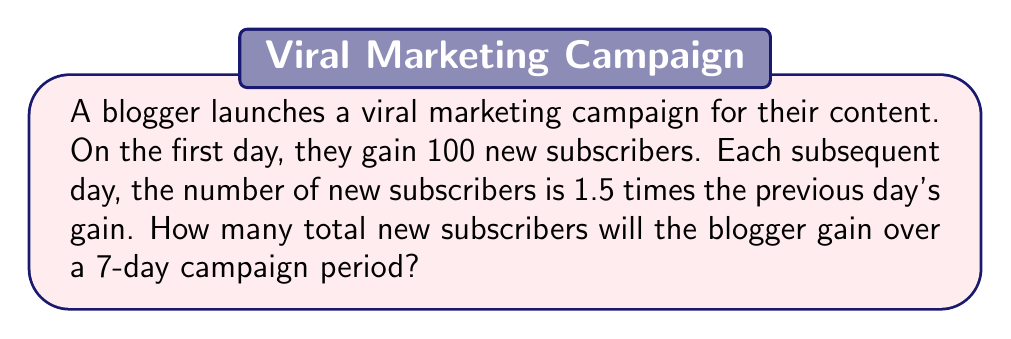Provide a solution to this math problem. Let's approach this step-by-step:

1) We can model this as a geometric sequence with:
   - First term: $a = 100$
   - Common ratio: $r = 1.5$
   - Number of terms: $n = 7$

2) The formula for the sum of a geometric sequence is:
   $$S_n = \frac{a(1-r^n)}{1-r}$$
   Where $S_n$ is the sum of the first $n$ terms.

3) Substituting our values:
   $$S_7 = \frac{100(1-1.5^7)}{1-1.5}$$

4) Let's calculate $1.5^7$:
   $$1.5^7 \approx 17.0859375$$

5) Now we can solve:
   $$S_7 = \frac{100(1-17.0859375)}{1-1.5}$$
   $$= \frac{100(-16.0859375)}{-0.5}$$
   $$= 3217.1875$$

6) Since we're dealing with subscribers, we need to round to the nearest whole number.
Answer: 3,217 new subscribers 